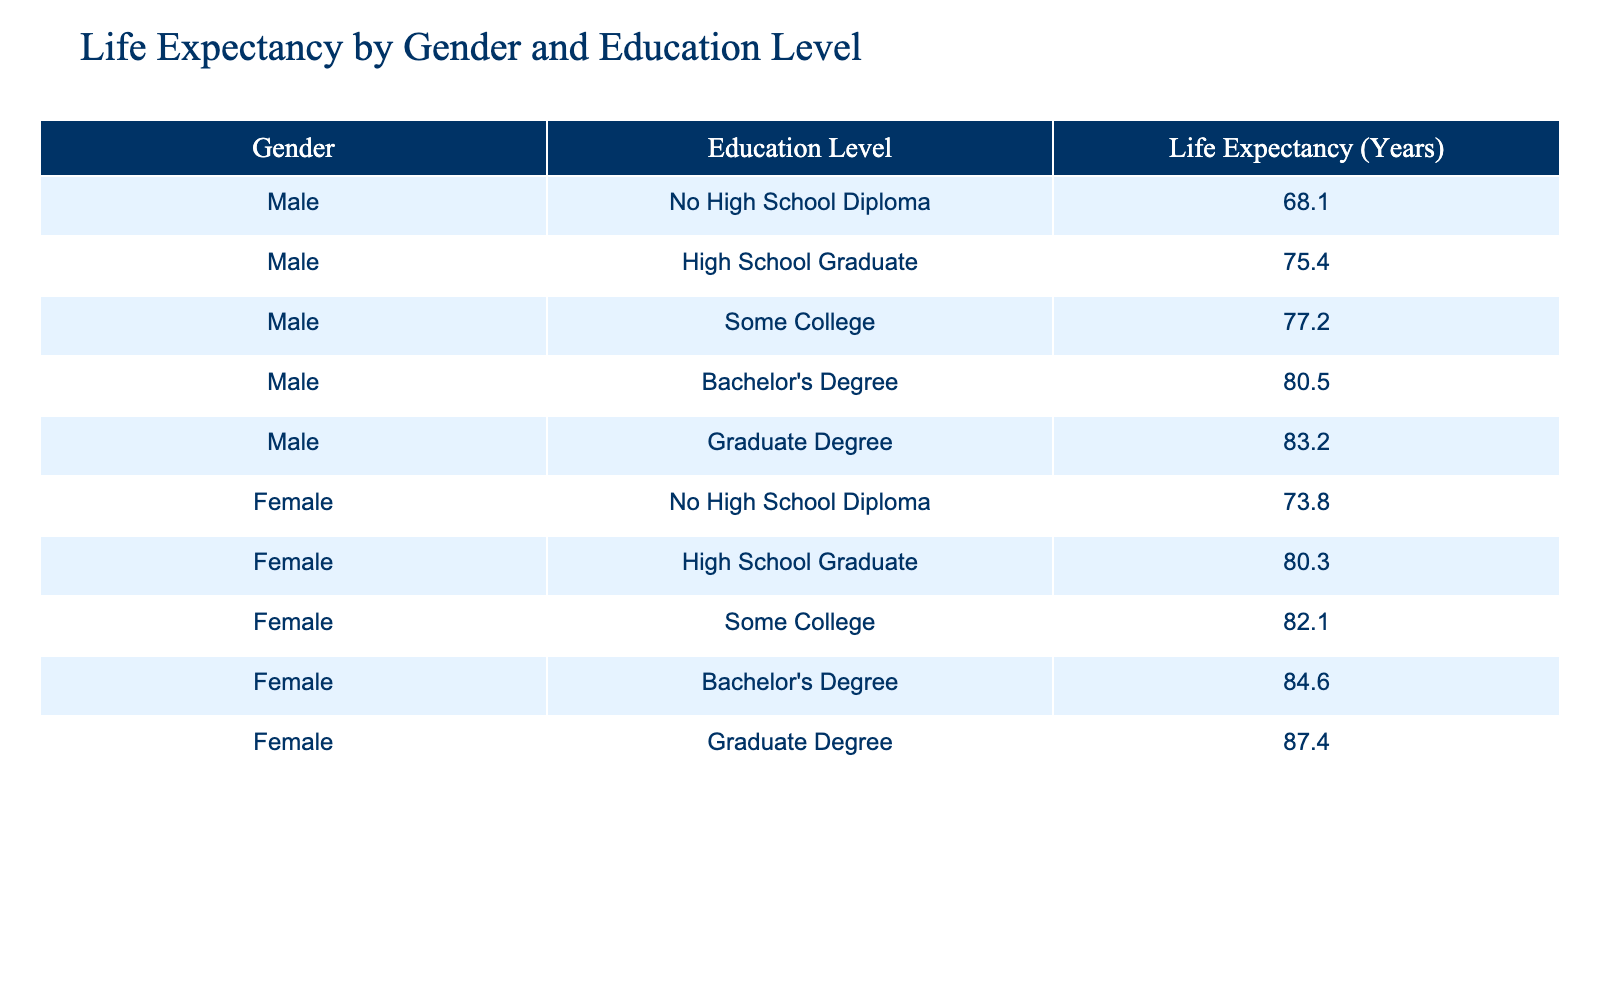What is the life expectancy for males with a graduate degree? The table shows that the life expectancy for males with a graduate degree is 83.2 years.
Answer: 83.2 What is the life expectancy for females with no high school diploma? According to the table, the life expectancy for females with no high school diploma is 73.8 years.
Answer: 73.8 Which gender has a higher life expectancy at the bachelor's degree level? For bachelor's degree holders, females have a life expectancy of 84.6 years, while males have 80.5 years, indicating females have a higher life expectancy.
Answer: Yes What is the difference in life expectancy between males with a high school diploma and females with a high school diploma? Males with a high school diploma have a life expectancy of 75.4 years, while females have 80.3 years. The difference is 80.3 - 75.4 = 4.9 years.
Answer: 4.9 What is the average life expectancy for both genders with some college education? The life expectancy for males with some college is 77.2 years and for females, it is 82.1 years. The average is (77.2 + 82.1) / 2 = 79.65 years.
Answer: 79.65 Is the life expectancy for males with a bachelor's degree higher than the life expectancy for females with some college education? Males with a bachelor's degree have a life expectancy of 80.5 years, while females with some college education have 82.1 years. Since 80.5 is less than 82.1, the statement is false.
Answer: No What is the highest life expectancy recorded in the table, and for which gender and education level? The highest life expectancy is 87.4 years, which is for females with a graduate degree.
Answer: 87.4 (females, graduate degree) What is the combined life expectancy for males with no high school diploma and females with no high school diploma? The life expectancy for males with no high school diploma is 68.1 years and for females, it is 73.8 years. The combined life expectancy is 68.1 + 73.8 = 141.9 years.
Answer: 141.9 Which education level has the largest difference in life expectancy between genders? The largest difference is between individuals with a graduate degree. Males have a life expectancy of 83.2 years, while females have 87.4 years, resulting in a difference of 87.4 - 83.2 = 4.2 years.
Answer: 4.2 